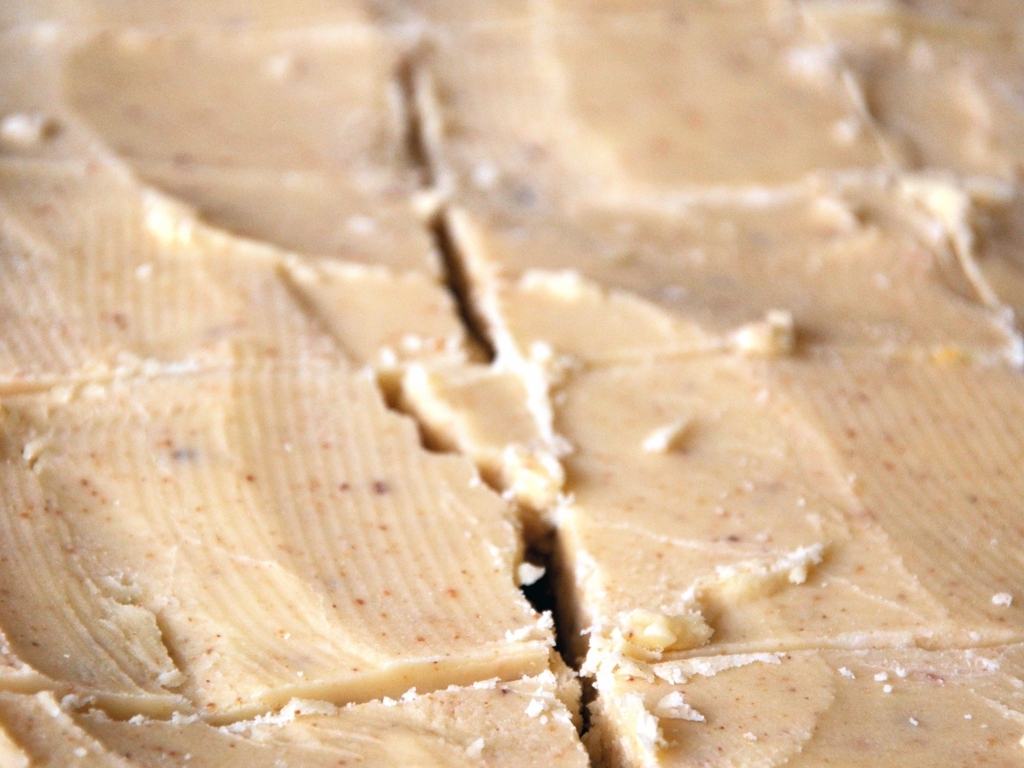Are there any quality issues with this image? Yes, there are visible quality issues with the image, including pixelation and a lack of sharpness that suggest it may have a low resolution, and there's overexposure, which affects the color balance and details. 